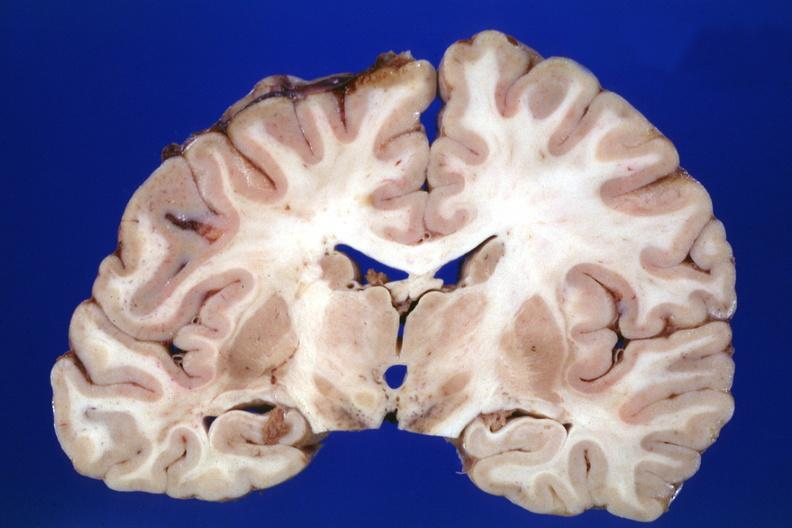what shows no lesion the lesion was in the pons?
Answer the question using a single word or phrase. Coronal section cerebral hemispheres case of diabetic cardiomyopathy with history of left hemisphere stroke slides 